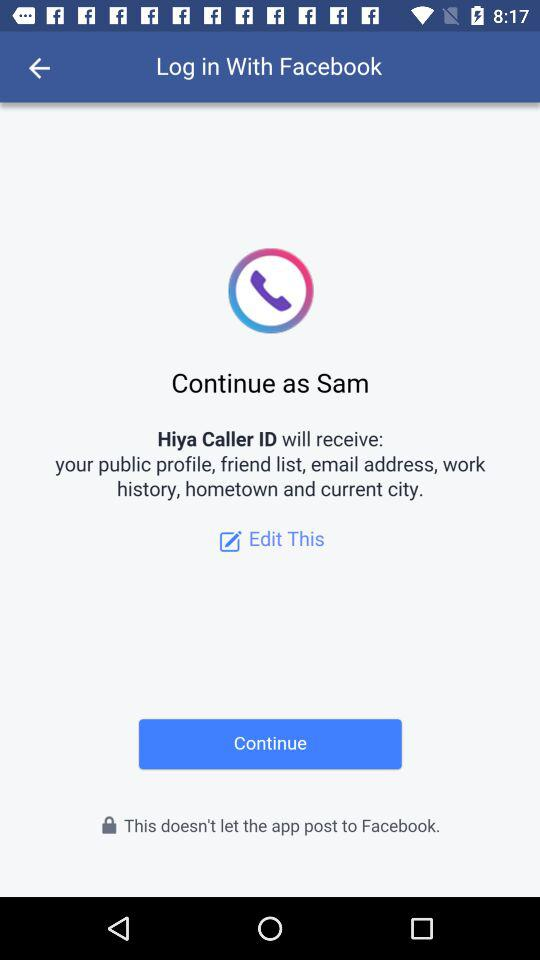What is the user name? The user name is Sam. 